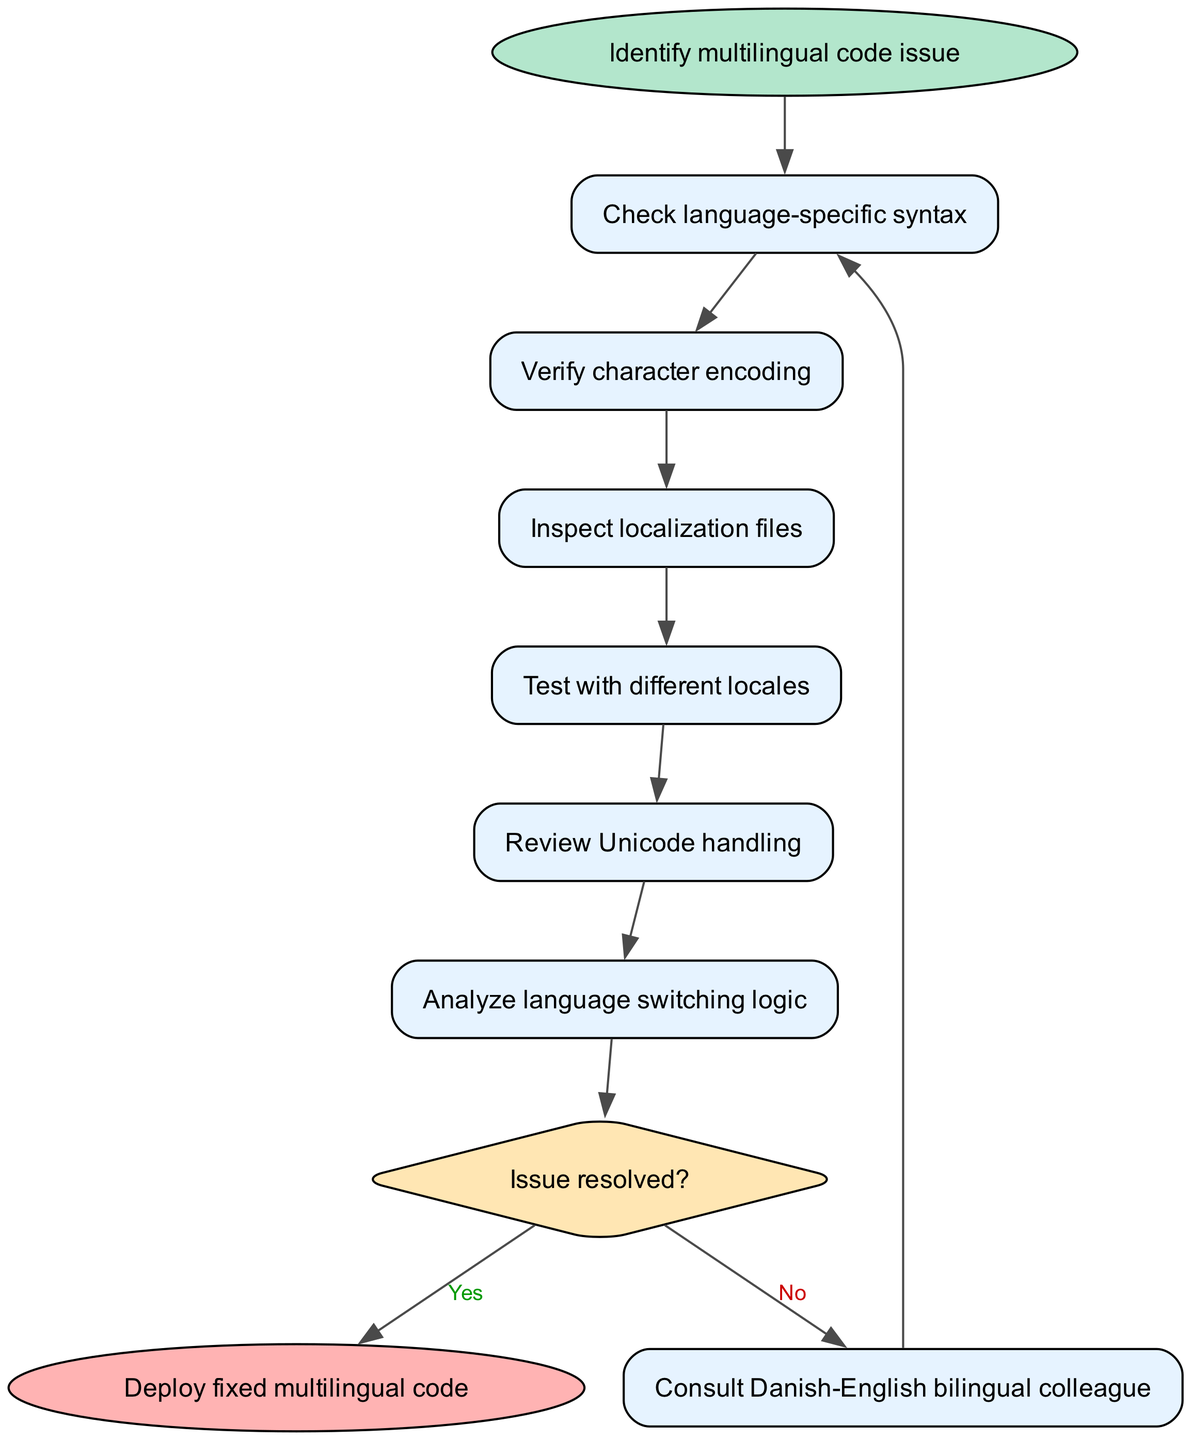What is the first step in the debugging procedure? The first step in the debugging procedure, as indicated in the diagram, is to "Identify multilingual code issue". This is the starting point from which all subsequent actions flow.
Answer: Identify multilingual code issue How many steps are in the debugging process? The diagram outlines a total of 8 steps before reaching the end node. This includes both decision points and sequential steps, from checking language-specific syntax to consulting a colleague if the issue is unresolved.
Answer: 8 What node follows "Inspect localization files"? According to the diagram, after "Inspect localization files", the next step is "Test with different locales". This is shown as a direct progression from one action to the next in the flowchart.
Answer: Test with different locales What is the final action in the diagram? The final action in the diagram is "Deploy fixed multilingual code". This represents the conclusion of the debugging process once the issue is resolved.
Answer: Deploy fixed multilingual code What happens if "Issue resolved?" is answered with "No"? If "Issue resolved?" is answered with "No", the next step in the flowchart is to "Consult Danish-English bilingual colleague". This indicates a loop back to the beginning of the troubleshooting process to seek additional help.
Answer: Consult Danish-English bilingual colleague How does the decision node affect the debugging process? The decision node marked "Issue resolved?" directs the flow of the process based on the answer given. If "Yes" is chosen, it leads straight to the end. If "No" is selected, it routes back to consult a colleague, impacting the overall progression of the debugging effort.
Answer: It decides the next step based on resolution status What is the character encoding step in the process? The character encoding step in the debugging process is "Verify character encoding". This step follows checking language-specific syntax and precedes inspecting localization files, highlighting a crucial aspect of handling multilingual code issues.
Answer: Verify character encoding Which step involves reviewing how languages switch in the application? The step that involves reviewing how languages switch in the application is "Analyze language switching logic". This occurs after verifying Unicode handling, indicating a concentrated focus on the functionality of language transitions in the multilingual code.
Answer: Analyze language switching logic 